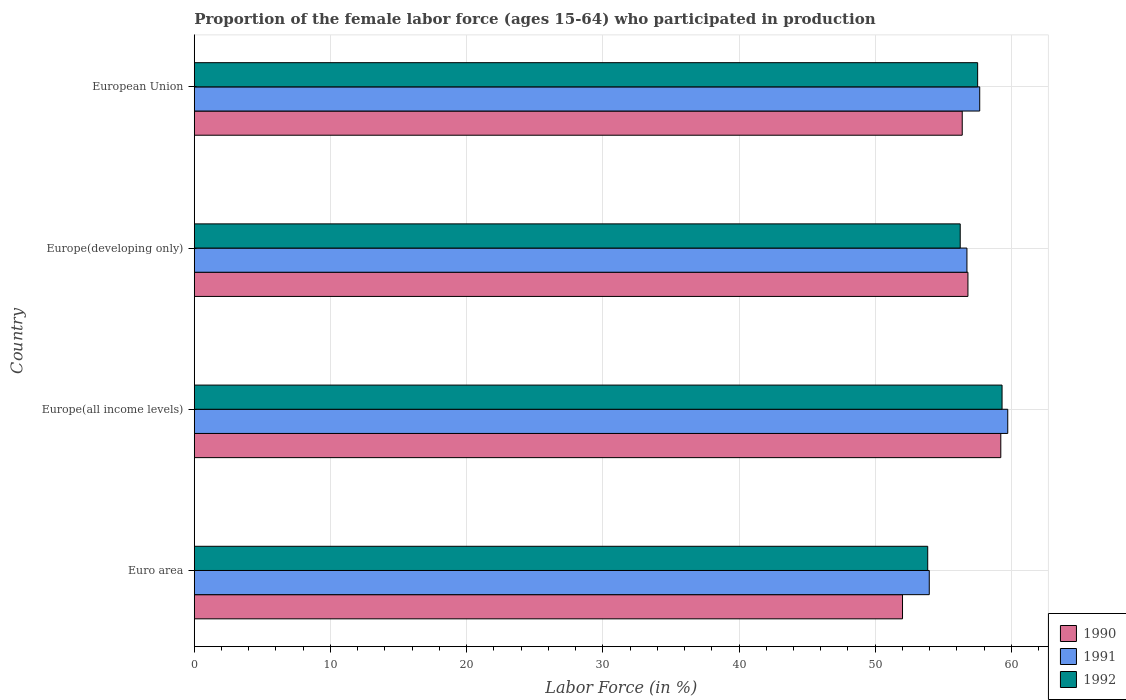How many different coloured bars are there?
Ensure brevity in your answer.  3. How many groups of bars are there?
Offer a terse response. 4. Are the number of bars per tick equal to the number of legend labels?
Ensure brevity in your answer.  Yes. How many bars are there on the 1st tick from the top?
Offer a terse response. 3. What is the label of the 1st group of bars from the top?
Your answer should be very brief. European Union. In how many cases, is the number of bars for a given country not equal to the number of legend labels?
Offer a very short reply. 0. What is the proportion of the female labor force who participated in production in 1991 in Europe(all income levels)?
Give a very brief answer. 59.73. Across all countries, what is the maximum proportion of the female labor force who participated in production in 1991?
Your response must be concise. 59.73. Across all countries, what is the minimum proportion of the female labor force who participated in production in 1991?
Provide a short and direct response. 53.97. In which country was the proportion of the female labor force who participated in production in 1991 maximum?
Provide a succinct answer. Europe(all income levels). In which country was the proportion of the female labor force who participated in production in 1992 minimum?
Keep it short and to the point. Euro area. What is the total proportion of the female labor force who participated in production in 1992 in the graph?
Ensure brevity in your answer.  226.94. What is the difference between the proportion of the female labor force who participated in production in 1992 in Euro area and that in Europe(all income levels)?
Offer a terse response. -5.46. What is the difference between the proportion of the female labor force who participated in production in 1992 in Euro area and the proportion of the female labor force who participated in production in 1991 in European Union?
Offer a very short reply. -3.82. What is the average proportion of the female labor force who participated in production in 1990 per country?
Offer a very short reply. 56.11. What is the difference between the proportion of the female labor force who participated in production in 1990 and proportion of the female labor force who participated in production in 1992 in Europe(developing only)?
Ensure brevity in your answer.  0.57. What is the ratio of the proportion of the female labor force who participated in production in 1990 in Europe(developing only) to that in European Union?
Give a very brief answer. 1.01. What is the difference between the highest and the second highest proportion of the female labor force who participated in production in 1992?
Offer a terse response. 1.79. What is the difference between the highest and the lowest proportion of the female labor force who participated in production in 1991?
Provide a succinct answer. 5.76. In how many countries, is the proportion of the female labor force who participated in production in 1990 greater than the average proportion of the female labor force who participated in production in 1990 taken over all countries?
Give a very brief answer. 3. Is the sum of the proportion of the female labor force who participated in production in 1992 in Europe(all income levels) and European Union greater than the maximum proportion of the female labor force who participated in production in 1991 across all countries?
Give a very brief answer. Yes. What does the 3rd bar from the bottom in Europe(developing only) represents?
Provide a succinct answer. 1992. How many bars are there?
Your answer should be very brief. 12. Are all the bars in the graph horizontal?
Offer a very short reply. Yes. How many countries are there in the graph?
Keep it short and to the point. 4. What is the difference between two consecutive major ticks on the X-axis?
Make the answer very short. 10. Are the values on the major ticks of X-axis written in scientific E-notation?
Provide a succinct answer. No. Does the graph contain any zero values?
Give a very brief answer. No. Does the graph contain grids?
Keep it short and to the point. Yes. How many legend labels are there?
Provide a short and direct response. 3. What is the title of the graph?
Ensure brevity in your answer.  Proportion of the female labor force (ages 15-64) who participated in production. What is the label or title of the Y-axis?
Offer a very short reply. Country. What is the Labor Force (in %) in 1990 in Euro area?
Make the answer very short. 52.01. What is the Labor Force (in %) of 1991 in Euro area?
Offer a very short reply. 53.97. What is the Labor Force (in %) of 1992 in Euro area?
Ensure brevity in your answer.  53.86. What is the Labor Force (in %) of 1990 in Europe(all income levels)?
Ensure brevity in your answer.  59.22. What is the Labor Force (in %) in 1991 in Europe(all income levels)?
Make the answer very short. 59.73. What is the Labor Force (in %) in 1992 in Europe(all income levels)?
Give a very brief answer. 59.32. What is the Labor Force (in %) of 1990 in Europe(developing only)?
Offer a very short reply. 56.81. What is the Labor Force (in %) in 1991 in Europe(developing only)?
Your answer should be compact. 56.74. What is the Labor Force (in %) of 1992 in Europe(developing only)?
Give a very brief answer. 56.24. What is the Labor Force (in %) of 1990 in European Union?
Give a very brief answer. 56.39. What is the Labor Force (in %) in 1991 in European Union?
Keep it short and to the point. 57.67. What is the Labor Force (in %) of 1992 in European Union?
Your answer should be compact. 57.52. Across all countries, what is the maximum Labor Force (in %) of 1990?
Your response must be concise. 59.22. Across all countries, what is the maximum Labor Force (in %) in 1991?
Provide a succinct answer. 59.73. Across all countries, what is the maximum Labor Force (in %) of 1992?
Your answer should be compact. 59.32. Across all countries, what is the minimum Labor Force (in %) of 1990?
Your response must be concise. 52.01. Across all countries, what is the minimum Labor Force (in %) in 1991?
Your response must be concise. 53.97. Across all countries, what is the minimum Labor Force (in %) of 1992?
Your answer should be very brief. 53.86. What is the total Labor Force (in %) in 1990 in the graph?
Your answer should be compact. 224.43. What is the total Labor Force (in %) of 1991 in the graph?
Ensure brevity in your answer.  228.11. What is the total Labor Force (in %) of 1992 in the graph?
Provide a succinct answer. 226.94. What is the difference between the Labor Force (in %) in 1990 in Euro area and that in Europe(all income levels)?
Your response must be concise. -7.22. What is the difference between the Labor Force (in %) of 1991 in Euro area and that in Europe(all income levels)?
Provide a succinct answer. -5.76. What is the difference between the Labor Force (in %) in 1992 in Euro area and that in Europe(all income levels)?
Provide a succinct answer. -5.46. What is the difference between the Labor Force (in %) in 1990 in Euro area and that in Europe(developing only)?
Make the answer very short. -4.8. What is the difference between the Labor Force (in %) in 1991 in Euro area and that in Europe(developing only)?
Your answer should be very brief. -2.77. What is the difference between the Labor Force (in %) in 1992 in Euro area and that in Europe(developing only)?
Give a very brief answer. -2.39. What is the difference between the Labor Force (in %) of 1990 in Euro area and that in European Union?
Keep it short and to the point. -4.38. What is the difference between the Labor Force (in %) in 1991 in Euro area and that in European Union?
Give a very brief answer. -3.7. What is the difference between the Labor Force (in %) of 1992 in Euro area and that in European Union?
Your response must be concise. -3.67. What is the difference between the Labor Force (in %) in 1990 in Europe(all income levels) and that in Europe(developing only)?
Your response must be concise. 2.41. What is the difference between the Labor Force (in %) of 1991 in Europe(all income levels) and that in Europe(developing only)?
Keep it short and to the point. 3. What is the difference between the Labor Force (in %) of 1992 in Europe(all income levels) and that in Europe(developing only)?
Provide a succinct answer. 3.07. What is the difference between the Labor Force (in %) of 1990 in Europe(all income levels) and that in European Union?
Your answer should be compact. 2.83. What is the difference between the Labor Force (in %) of 1991 in Europe(all income levels) and that in European Union?
Offer a very short reply. 2.06. What is the difference between the Labor Force (in %) in 1992 in Europe(all income levels) and that in European Union?
Provide a short and direct response. 1.79. What is the difference between the Labor Force (in %) in 1990 in Europe(developing only) and that in European Union?
Offer a terse response. 0.42. What is the difference between the Labor Force (in %) of 1991 in Europe(developing only) and that in European Union?
Give a very brief answer. -0.94. What is the difference between the Labor Force (in %) of 1992 in Europe(developing only) and that in European Union?
Offer a very short reply. -1.28. What is the difference between the Labor Force (in %) of 1990 in Euro area and the Labor Force (in %) of 1991 in Europe(all income levels)?
Give a very brief answer. -7.73. What is the difference between the Labor Force (in %) of 1990 in Euro area and the Labor Force (in %) of 1992 in Europe(all income levels)?
Keep it short and to the point. -7.31. What is the difference between the Labor Force (in %) in 1991 in Euro area and the Labor Force (in %) in 1992 in Europe(all income levels)?
Keep it short and to the point. -5.34. What is the difference between the Labor Force (in %) of 1990 in Euro area and the Labor Force (in %) of 1991 in Europe(developing only)?
Offer a very short reply. -4.73. What is the difference between the Labor Force (in %) in 1990 in Euro area and the Labor Force (in %) in 1992 in Europe(developing only)?
Provide a short and direct response. -4.24. What is the difference between the Labor Force (in %) in 1991 in Euro area and the Labor Force (in %) in 1992 in Europe(developing only)?
Make the answer very short. -2.27. What is the difference between the Labor Force (in %) in 1990 in Euro area and the Labor Force (in %) in 1991 in European Union?
Give a very brief answer. -5.67. What is the difference between the Labor Force (in %) of 1990 in Euro area and the Labor Force (in %) of 1992 in European Union?
Provide a succinct answer. -5.52. What is the difference between the Labor Force (in %) in 1991 in Euro area and the Labor Force (in %) in 1992 in European Union?
Offer a very short reply. -3.55. What is the difference between the Labor Force (in %) of 1990 in Europe(all income levels) and the Labor Force (in %) of 1991 in Europe(developing only)?
Your answer should be very brief. 2.49. What is the difference between the Labor Force (in %) of 1990 in Europe(all income levels) and the Labor Force (in %) of 1992 in Europe(developing only)?
Offer a very short reply. 2.98. What is the difference between the Labor Force (in %) in 1991 in Europe(all income levels) and the Labor Force (in %) in 1992 in Europe(developing only)?
Give a very brief answer. 3.49. What is the difference between the Labor Force (in %) in 1990 in Europe(all income levels) and the Labor Force (in %) in 1991 in European Union?
Provide a short and direct response. 1.55. What is the difference between the Labor Force (in %) in 1990 in Europe(all income levels) and the Labor Force (in %) in 1992 in European Union?
Provide a short and direct response. 1.7. What is the difference between the Labor Force (in %) of 1991 in Europe(all income levels) and the Labor Force (in %) of 1992 in European Union?
Your response must be concise. 2.21. What is the difference between the Labor Force (in %) of 1990 in Europe(developing only) and the Labor Force (in %) of 1991 in European Union?
Give a very brief answer. -0.87. What is the difference between the Labor Force (in %) in 1990 in Europe(developing only) and the Labor Force (in %) in 1992 in European Union?
Your response must be concise. -0.71. What is the difference between the Labor Force (in %) of 1991 in Europe(developing only) and the Labor Force (in %) of 1992 in European Union?
Provide a short and direct response. -0.79. What is the average Labor Force (in %) in 1990 per country?
Provide a short and direct response. 56.11. What is the average Labor Force (in %) of 1991 per country?
Ensure brevity in your answer.  57.03. What is the average Labor Force (in %) in 1992 per country?
Make the answer very short. 56.73. What is the difference between the Labor Force (in %) in 1990 and Labor Force (in %) in 1991 in Euro area?
Provide a succinct answer. -1.96. What is the difference between the Labor Force (in %) in 1990 and Labor Force (in %) in 1992 in Euro area?
Give a very brief answer. -1.85. What is the difference between the Labor Force (in %) in 1991 and Labor Force (in %) in 1992 in Euro area?
Offer a very short reply. 0.11. What is the difference between the Labor Force (in %) in 1990 and Labor Force (in %) in 1991 in Europe(all income levels)?
Keep it short and to the point. -0.51. What is the difference between the Labor Force (in %) of 1990 and Labor Force (in %) of 1992 in Europe(all income levels)?
Provide a short and direct response. -0.09. What is the difference between the Labor Force (in %) of 1991 and Labor Force (in %) of 1992 in Europe(all income levels)?
Your response must be concise. 0.42. What is the difference between the Labor Force (in %) of 1990 and Labor Force (in %) of 1991 in Europe(developing only)?
Offer a terse response. 0.07. What is the difference between the Labor Force (in %) in 1990 and Labor Force (in %) in 1992 in Europe(developing only)?
Your answer should be very brief. 0.57. What is the difference between the Labor Force (in %) in 1991 and Labor Force (in %) in 1992 in Europe(developing only)?
Provide a succinct answer. 0.49. What is the difference between the Labor Force (in %) of 1990 and Labor Force (in %) of 1991 in European Union?
Give a very brief answer. -1.28. What is the difference between the Labor Force (in %) in 1990 and Labor Force (in %) in 1992 in European Union?
Your answer should be very brief. -1.13. What is the difference between the Labor Force (in %) in 1991 and Labor Force (in %) in 1992 in European Union?
Provide a succinct answer. 0.15. What is the ratio of the Labor Force (in %) in 1990 in Euro area to that in Europe(all income levels)?
Ensure brevity in your answer.  0.88. What is the ratio of the Labor Force (in %) in 1991 in Euro area to that in Europe(all income levels)?
Provide a succinct answer. 0.9. What is the ratio of the Labor Force (in %) in 1992 in Euro area to that in Europe(all income levels)?
Provide a short and direct response. 0.91. What is the ratio of the Labor Force (in %) in 1990 in Euro area to that in Europe(developing only)?
Offer a very short reply. 0.92. What is the ratio of the Labor Force (in %) of 1991 in Euro area to that in Europe(developing only)?
Your answer should be compact. 0.95. What is the ratio of the Labor Force (in %) of 1992 in Euro area to that in Europe(developing only)?
Offer a very short reply. 0.96. What is the ratio of the Labor Force (in %) of 1990 in Euro area to that in European Union?
Your response must be concise. 0.92. What is the ratio of the Labor Force (in %) of 1991 in Euro area to that in European Union?
Ensure brevity in your answer.  0.94. What is the ratio of the Labor Force (in %) in 1992 in Euro area to that in European Union?
Provide a short and direct response. 0.94. What is the ratio of the Labor Force (in %) in 1990 in Europe(all income levels) to that in Europe(developing only)?
Give a very brief answer. 1.04. What is the ratio of the Labor Force (in %) in 1991 in Europe(all income levels) to that in Europe(developing only)?
Keep it short and to the point. 1.05. What is the ratio of the Labor Force (in %) in 1992 in Europe(all income levels) to that in Europe(developing only)?
Offer a terse response. 1.05. What is the ratio of the Labor Force (in %) in 1990 in Europe(all income levels) to that in European Union?
Offer a terse response. 1.05. What is the ratio of the Labor Force (in %) of 1991 in Europe(all income levels) to that in European Union?
Keep it short and to the point. 1.04. What is the ratio of the Labor Force (in %) of 1992 in Europe(all income levels) to that in European Union?
Offer a very short reply. 1.03. What is the ratio of the Labor Force (in %) of 1990 in Europe(developing only) to that in European Union?
Keep it short and to the point. 1.01. What is the ratio of the Labor Force (in %) in 1991 in Europe(developing only) to that in European Union?
Make the answer very short. 0.98. What is the ratio of the Labor Force (in %) in 1992 in Europe(developing only) to that in European Union?
Provide a short and direct response. 0.98. What is the difference between the highest and the second highest Labor Force (in %) of 1990?
Your answer should be very brief. 2.41. What is the difference between the highest and the second highest Labor Force (in %) of 1991?
Your answer should be very brief. 2.06. What is the difference between the highest and the second highest Labor Force (in %) in 1992?
Provide a succinct answer. 1.79. What is the difference between the highest and the lowest Labor Force (in %) of 1990?
Offer a terse response. 7.22. What is the difference between the highest and the lowest Labor Force (in %) in 1991?
Your answer should be compact. 5.76. What is the difference between the highest and the lowest Labor Force (in %) in 1992?
Your response must be concise. 5.46. 